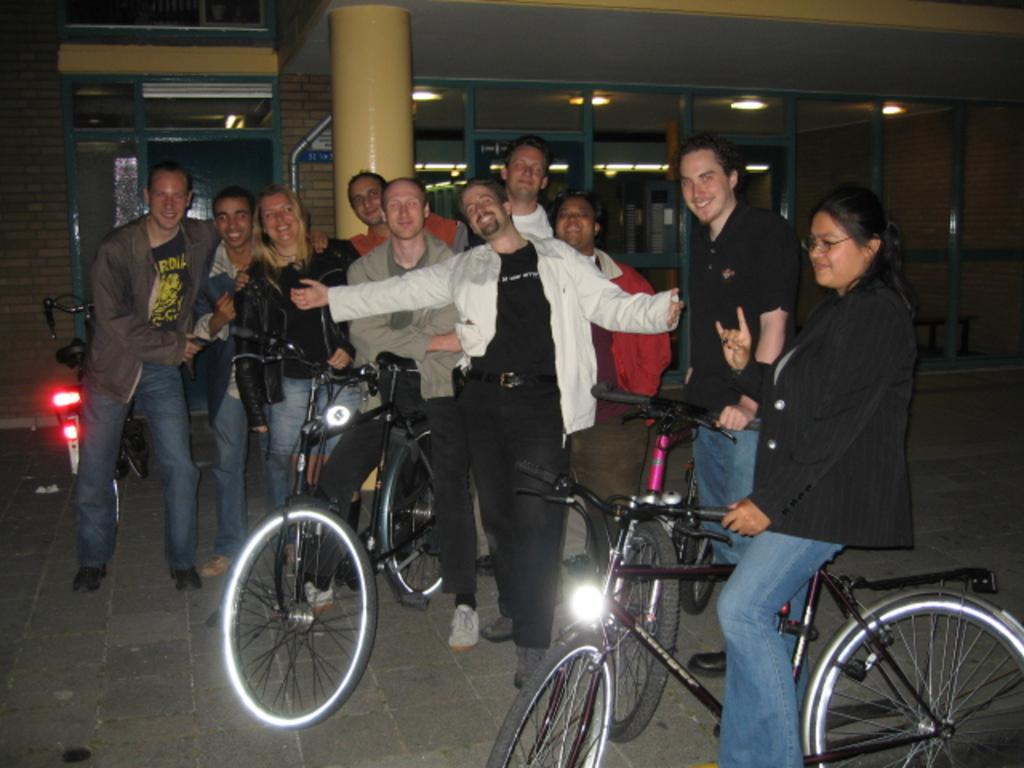How many people are in the image? There is a group of people in the image. What objects related to transportation can be seen in the image? There are three bicycles in the image. What can be seen in the background of the image? There is a pole, ceiling lights, and a glass door in the background of the image. What type of flowers are growing near the house in the image? There is no house or flowers present in the image. How many railway tracks are visible in the image? There are no railway tracks visible in the image. 